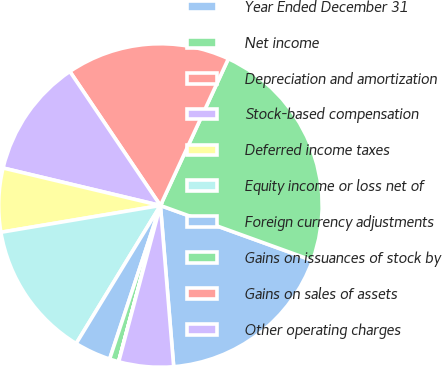Convert chart to OTSL. <chart><loc_0><loc_0><loc_500><loc_500><pie_chart><fcel>Year Ended December 31<fcel>Net income<fcel>Depreciation and amortization<fcel>Stock-based compensation<fcel>Deferred income taxes<fcel>Equity income or loss net of<fcel>Foreign currency adjustments<fcel>Gains on issuances of stock by<fcel>Gains on sales of assets<fcel>Other operating charges<nl><fcel>18.17%<fcel>23.62%<fcel>16.36%<fcel>11.82%<fcel>6.37%<fcel>13.63%<fcel>3.64%<fcel>0.92%<fcel>0.01%<fcel>5.46%<nl></chart> 